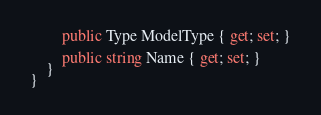Convert code to text. <code><loc_0><loc_0><loc_500><loc_500><_C#_>        public Type ModelType { get; set; }

        public string Name { get; set; }
    }
}</code> 